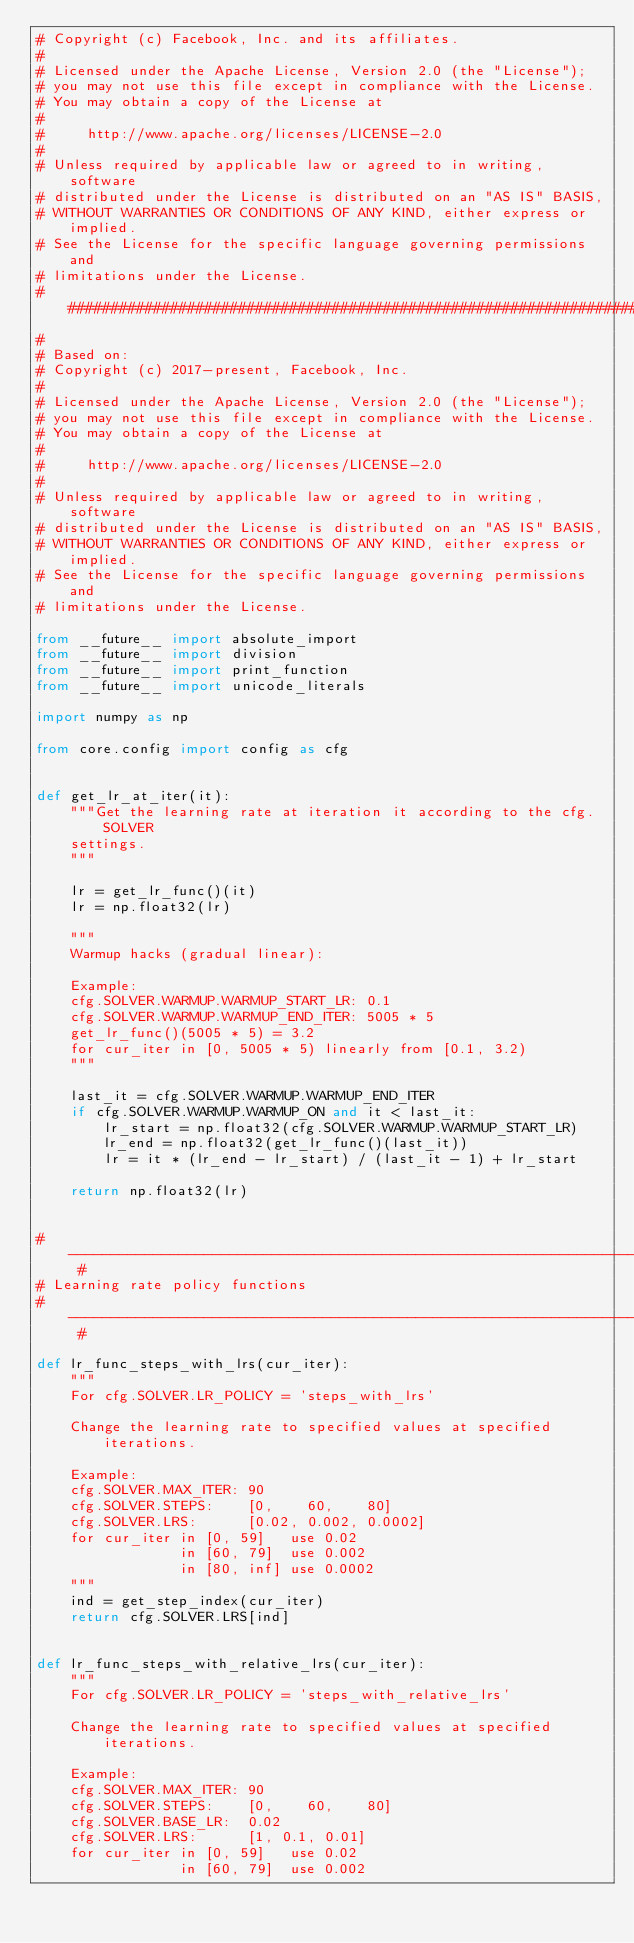Convert code to text. <code><loc_0><loc_0><loc_500><loc_500><_Python_># Copyright (c) Facebook, Inc. and its affiliates.
#
# Licensed under the Apache License, Version 2.0 (the "License");
# you may not use this file except in compliance with the License.
# You may obtain a copy of the License at
#
#     http://www.apache.org/licenses/LICENSE-2.0
#
# Unless required by applicable law or agreed to in writing, software
# distributed under the License is distributed on an "AS IS" BASIS,
# WITHOUT WARRANTIES OR CONDITIONS OF ANY KIND, either express or implied.
# See the License for the specific language governing permissions and
# limitations under the License.
##############################################################################
#
# Based on:
# Copyright (c) 2017-present, Facebook, Inc.
#
# Licensed under the Apache License, Version 2.0 (the "License");
# you may not use this file except in compliance with the License.
# You may obtain a copy of the License at
#
#     http://www.apache.org/licenses/LICENSE-2.0
#
# Unless required by applicable law or agreed to in writing, software
# distributed under the License is distributed on an "AS IS" BASIS,
# WITHOUT WARRANTIES OR CONDITIONS OF ANY KIND, either express or implied.
# See the License for the specific language governing permissions and
# limitations under the License.

from __future__ import absolute_import
from __future__ import division
from __future__ import print_function
from __future__ import unicode_literals

import numpy as np

from core.config import config as cfg


def get_lr_at_iter(it):
    """Get the learning rate at iteration it according to the cfg.SOLVER
    settings.
    """

    lr = get_lr_func()(it)
    lr = np.float32(lr)

    """
    Warmup hacks (gradual linear):

    Example:
    cfg.SOLVER.WARMUP.WARMUP_START_LR: 0.1
    cfg.SOLVER.WARMUP.WARMUP_END_ITER: 5005 * 5
    get_lr_func()(5005 * 5) = 3.2
    for cur_iter in [0, 5005 * 5) linearly from [0.1, 3.2)
    """

    last_it = cfg.SOLVER.WARMUP.WARMUP_END_ITER
    if cfg.SOLVER.WARMUP.WARMUP_ON and it < last_it:
        lr_start = np.float32(cfg.SOLVER.WARMUP.WARMUP_START_LR)
        lr_end = np.float32(get_lr_func()(last_it))
        lr = it * (lr_end - lr_start) / (last_it - 1) + lr_start

    return np.float32(lr)


# ---------------------------------------------------------------------------- #
# Learning rate policy functions
# ---------------------------------------------------------------------------- #

def lr_func_steps_with_lrs(cur_iter):
    """
    For cfg.SOLVER.LR_POLICY = 'steps_with_lrs'

    Change the learning rate to specified values at specified iterations.

    Example:
    cfg.SOLVER.MAX_ITER: 90
    cfg.SOLVER.STEPS:    [0,    60,    80]
    cfg.SOLVER.LRS:      [0.02, 0.002, 0.0002]
    for cur_iter in [0, 59]   use 0.02
                 in [60, 79]  use 0.002
                 in [80, inf] use 0.0002
    """
    ind = get_step_index(cur_iter)
    return cfg.SOLVER.LRS[ind]


def lr_func_steps_with_relative_lrs(cur_iter):
    """
    For cfg.SOLVER.LR_POLICY = 'steps_with_relative_lrs'

    Change the learning rate to specified values at specified iterations.

    Example:
    cfg.SOLVER.MAX_ITER: 90
    cfg.SOLVER.STEPS:    [0,    60,    80]
    cfg.SOLVER.BASE_LR:  0.02
    cfg.SOLVER.LRS:      [1, 0.1, 0.01]
    for cur_iter in [0, 59]   use 0.02
                 in [60, 79]  use 0.002</code> 